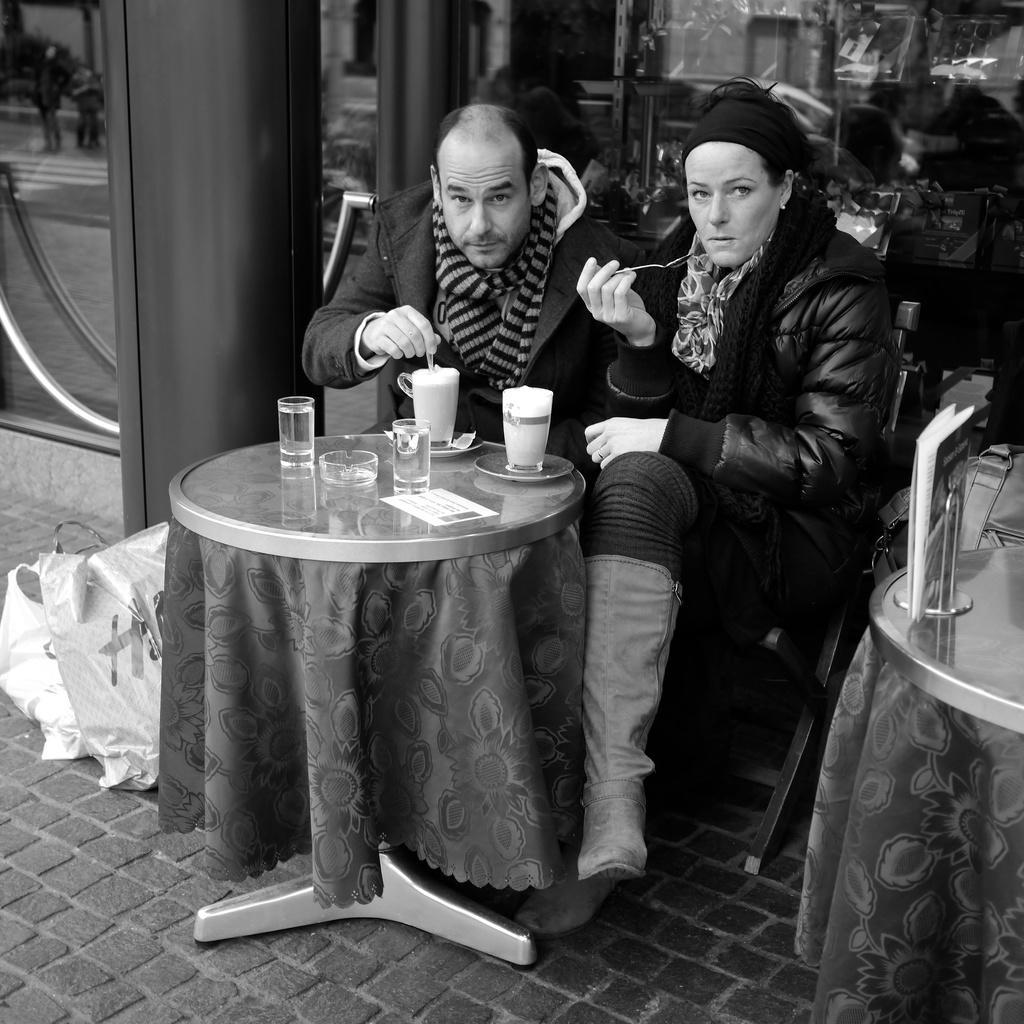How would you summarize this image in a sentence or two? There are two persons sitting in a chair and there is a table in front of them, Which contains glasses on it. 